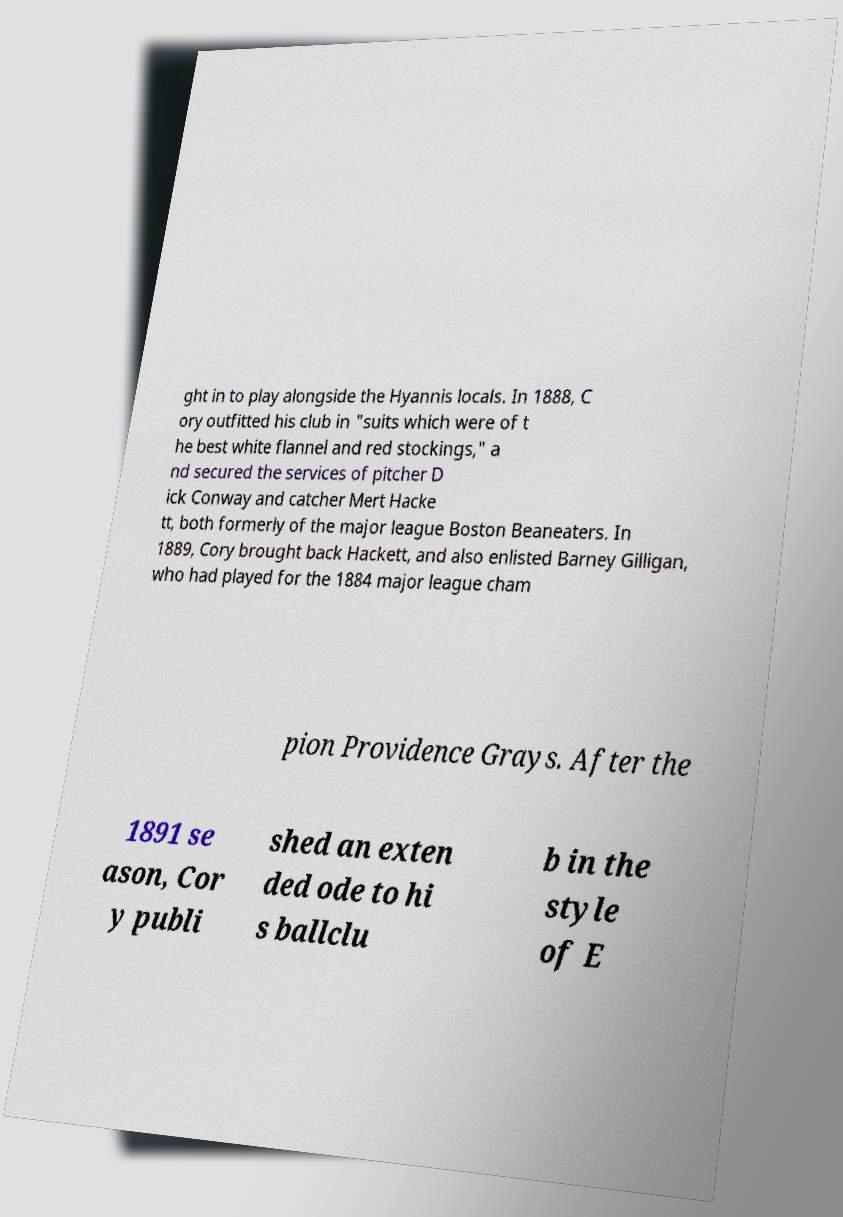Could you extract and type out the text from this image? ght in to play alongside the Hyannis locals. In 1888, C ory outfitted his club in "suits which were of t he best white flannel and red stockings," a nd secured the services of pitcher D ick Conway and catcher Mert Hacke tt, both formerly of the major league Boston Beaneaters. In 1889, Cory brought back Hackett, and also enlisted Barney Gilligan, who had played for the 1884 major league cham pion Providence Grays. After the 1891 se ason, Cor y publi shed an exten ded ode to hi s ballclu b in the style of E 